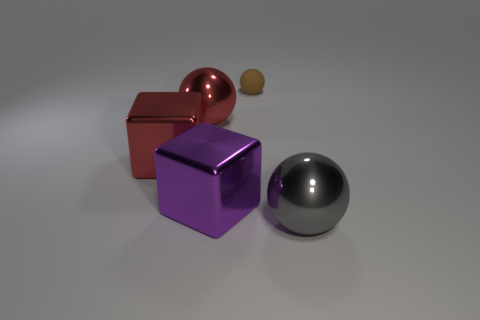Which objects in the picture could interact with magnets? The red metallic cube appears to be the most likely candidate to interact with magnets, presuming it is made from a magnetic material. 